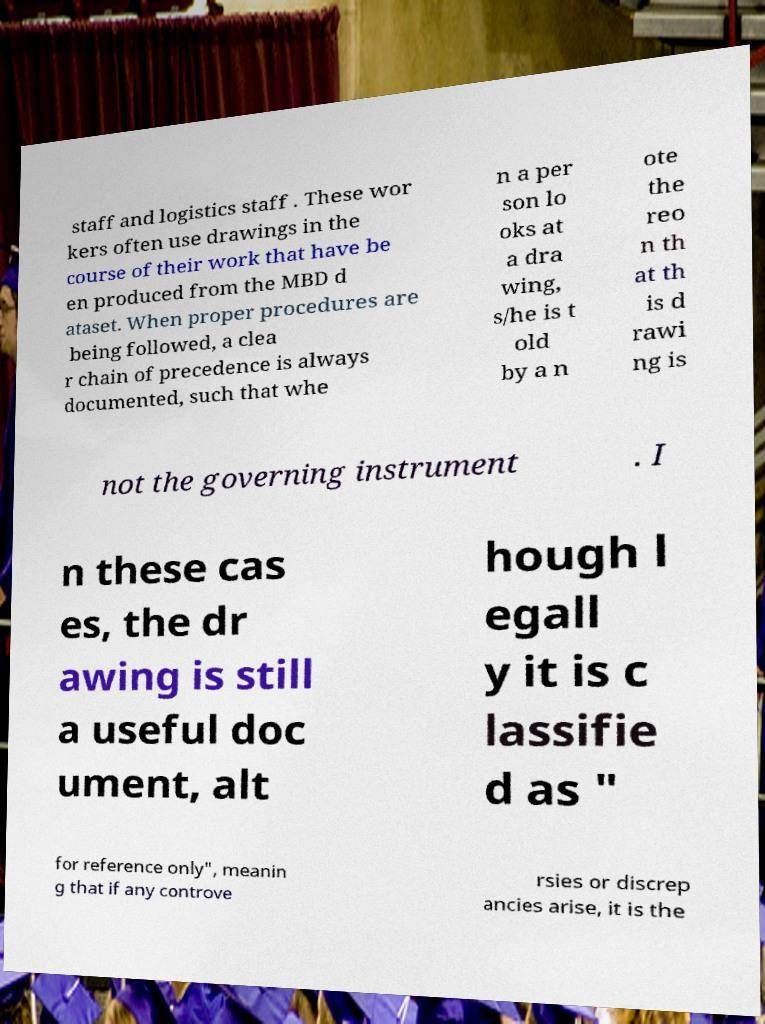Can you read and provide the text displayed in the image?This photo seems to have some interesting text. Can you extract and type it out for me? staff and logistics staff . These wor kers often use drawings in the course of their work that have be en produced from the MBD d ataset. When proper procedures are being followed, a clea r chain of precedence is always documented, such that whe n a per son lo oks at a dra wing, s/he is t old by a n ote the reo n th at th is d rawi ng is not the governing instrument . I n these cas es, the dr awing is still a useful doc ument, alt hough l egall y it is c lassifie d as " for reference only", meanin g that if any controve rsies or discrep ancies arise, it is the 